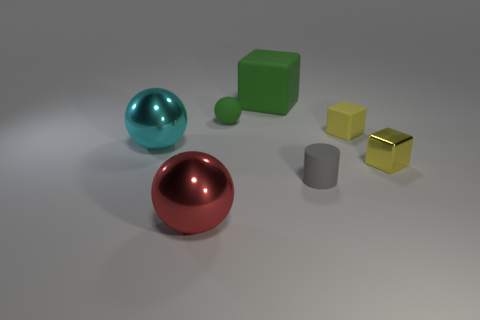Add 3 yellow blocks. How many objects exist? 10 Subtract all cylinders. How many objects are left? 6 Add 7 green matte things. How many green matte things are left? 9 Add 6 small metal blocks. How many small metal blocks exist? 7 Subtract 1 green spheres. How many objects are left? 6 Subtract all cubes. Subtract all yellow matte objects. How many objects are left? 3 